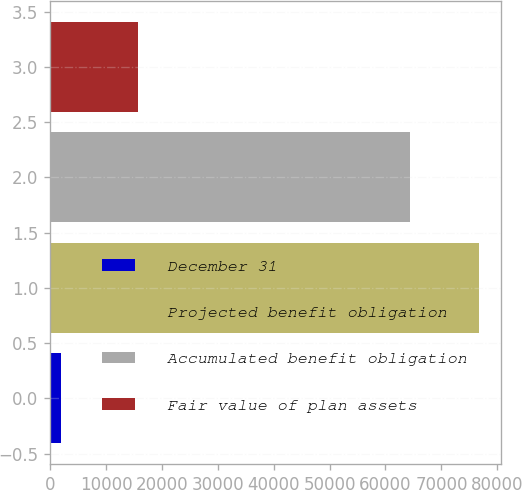Convert chart. <chart><loc_0><loc_0><loc_500><loc_500><bar_chart><fcel>December 31<fcel>Projected benefit obligation<fcel>Accumulated benefit obligation<fcel>Fair value of plan assets<nl><fcel>2013<fcel>76801<fcel>64340<fcel>15760<nl></chart> 